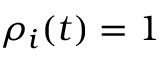<formula> <loc_0><loc_0><loc_500><loc_500>\rho _ { i } ( t ) = 1</formula> 